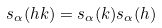<formula> <loc_0><loc_0><loc_500><loc_500>s _ { \alpha } ( h k ) = s _ { \alpha } ( k ) s _ { \alpha } ( h )</formula> 